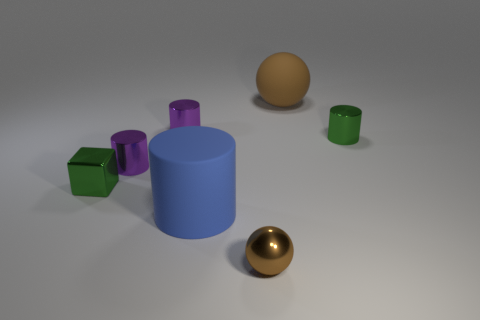Add 1 small brown metallic things. How many objects exist? 8 Subtract all cylinders. How many objects are left? 3 Subtract 0 green balls. How many objects are left? 7 Subtract all large balls. Subtract all large purple cubes. How many objects are left? 6 Add 1 large blue objects. How many large blue objects are left? 2 Add 6 tiny cylinders. How many tiny cylinders exist? 9 